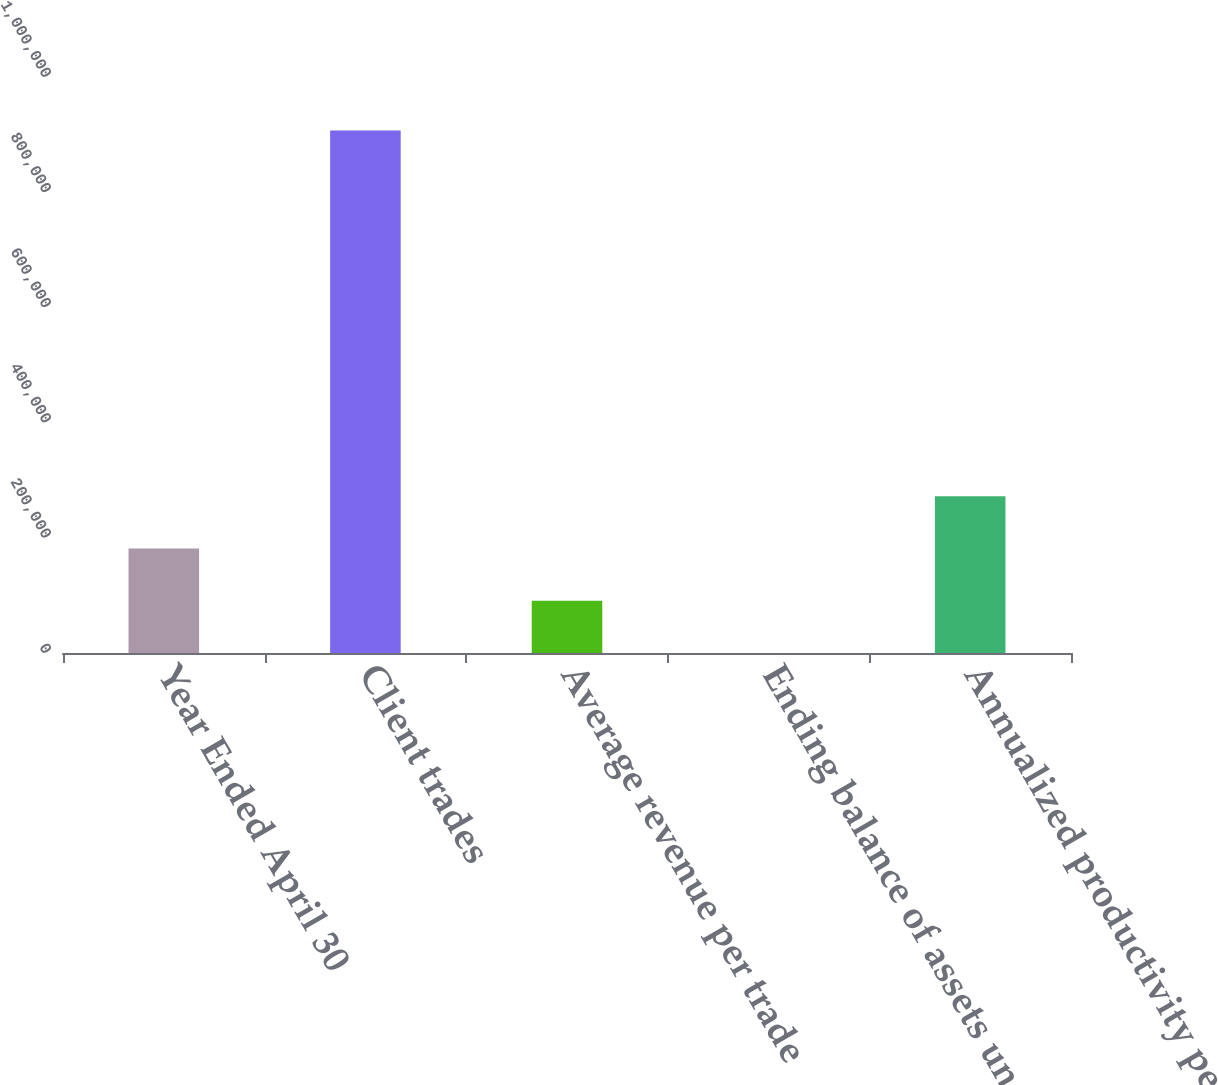<chart> <loc_0><loc_0><loc_500><loc_500><bar_chart><fcel>Year Ended April 30<fcel>Client trades<fcel>Average revenue per trade<fcel>Ending balance of assets under<fcel>Annualized productivity per<nl><fcel>181441<fcel>907075<fcel>90737.3<fcel>33.1<fcel>272146<nl></chart> 